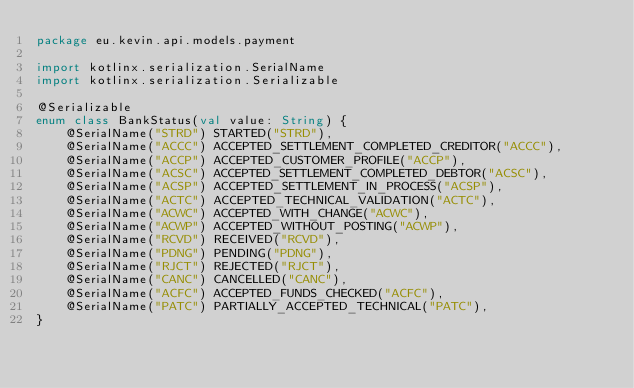<code> <loc_0><loc_0><loc_500><loc_500><_Kotlin_>package eu.kevin.api.models.payment

import kotlinx.serialization.SerialName
import kotlinx.serialization.Serializable

@Serializable
enum class BankStatus(val value: String) {
    @SerialName("STRD") STARTED("STRD"),
    @SerialName("ACCC") ACCEPTED_SETTLEMENT_COMPLETED_CREDITOR("ACCC"),
    @SerialName("ACCP") ACCEPTED_CUSTOMER_PROFILE("ACCP"),
    @SerialName("ACSC") ACCEPTED_SETTLEMENT_COMPLETED_DEBTOR("ACSC"),
    @SerialName("ACSP") ACCEPTED_SETTLEMENT_IN_PROCESS("ACSP"),
    @SerialName("ACTC") ACCEPTED_TECHNICAL_VALIDATION("ACTC"),
    @SerialName("ACWC") ACCEPTED_WITH_CHANGE("ACWC"),
    @SerialName("ACWP") ACCEPTED_WITHOUT_POSTING("ACWP"),
    @SerialName("RCVD") RECEIVED("RCVD"),
    @SerialName("PDNG") PENDING("PDNG"),
    @SerialName("RJCT") REJECTED("RJCT"),
    @SerialName("CANC") CANCELLED("CANC"),
    @SerialName("ACFC") ACCEPTED_FUNDS_CHECKED("ACFC"),
    @SerialName("PATC") PARTIALLY_ACCEPTED_TECHNICAL("PATC"),
}</code> 